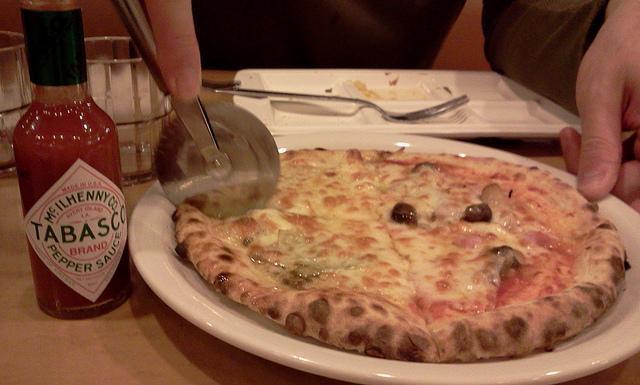The popular American brand of hot sauce is made up of what?
Make your selection from the four choices given to correctly answer the question.
Options: Chilly, tabasco peppers, peppercorn, capsicum. Tabasco peppers. 